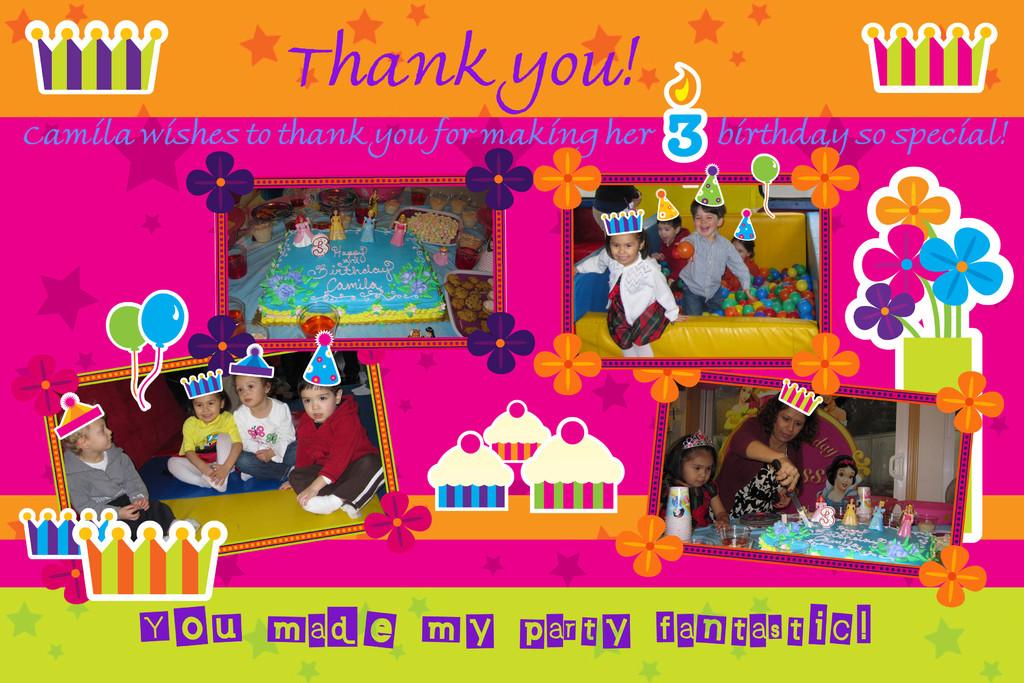What type of pictures are featured in the image? There are collage pictures of kids in the image. Can you describe the text at the top of the image? There is text at the top of the image, but we cannot determine its content without more information. Is there any text present at the bottom of the image? Yes, there is text at the bottom of the image. How many flowers are present in the image? There are no flowers visible in the image; it features collage pictures of kids and text. Can you describe the color of the giraffe in the image? There is no giraffe present in the image. 